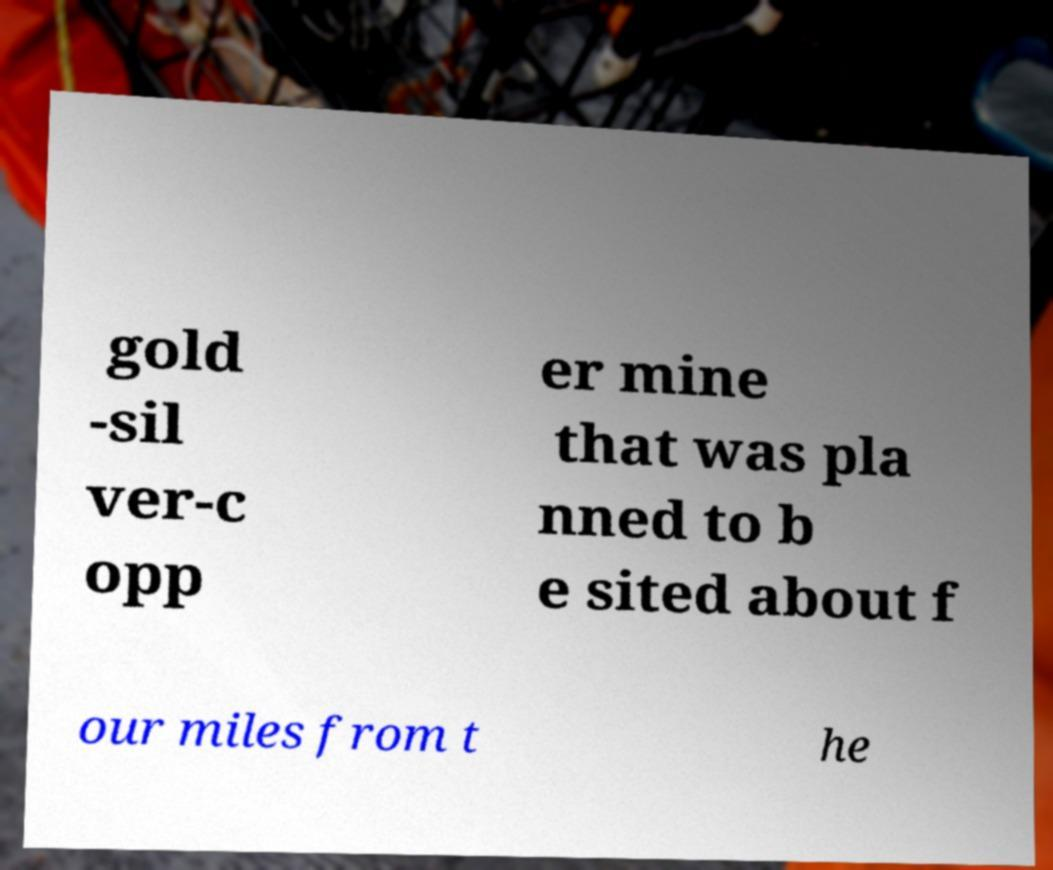Can you read and provide the text displayed in the image?This photo seems to have some interesting text. Can you extract and type it out for me? gold -sil ver-c opp er mine that was pla nned to b e sited about f our miles from t he 